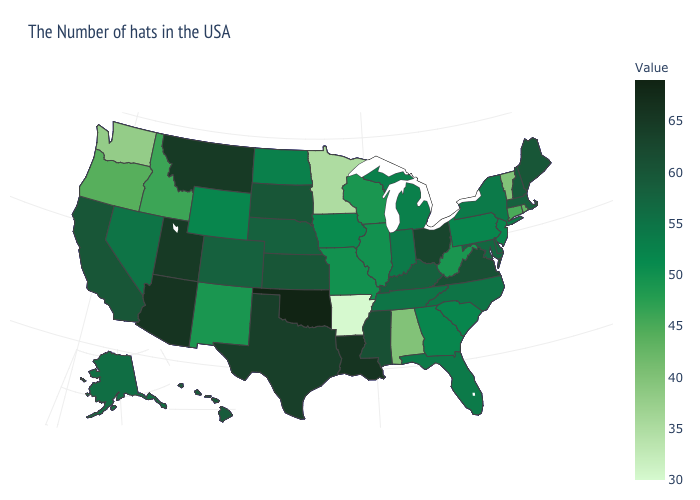Is the legend a continuous bar?
Be succinct. Yes. Does Wyoming have the lowest value in the West?
Keep it brief. No. Does New Hampshire have the lowest value in the Northeast?
Quick response, please. No. Which states hav the highest value in the West?
Answer briefly. Arizona. Among the states that border Arkansas , does Tennessee have the highest value?
Write a very short answer. No. Which states have the lowest value in the USA?
Write a very short answer. Arkansas. Does Alabama have the lowest value in the USA?
Be succinct. No. Does Arkansas have the lowest value in the USA?
Keep it brief. Yes. 